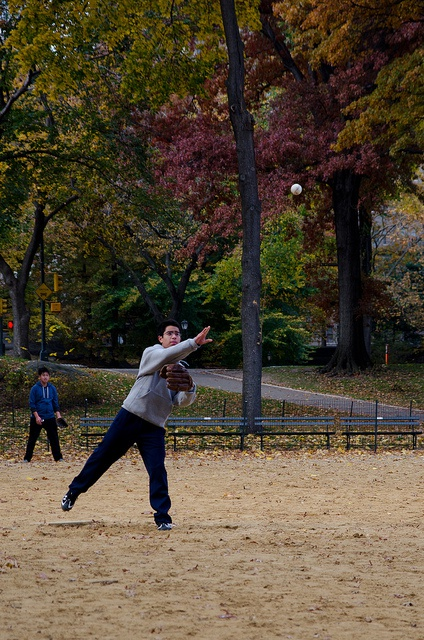Describe the objects in this image and their specific colors. I can see people in black, gray, darkgray, and navy tones, people in black, navy, maroon, and brown tones, bench in black, gray, and maroon tones, bench in black, olive, and gray tones, and bench in black and gray tones in this image. 